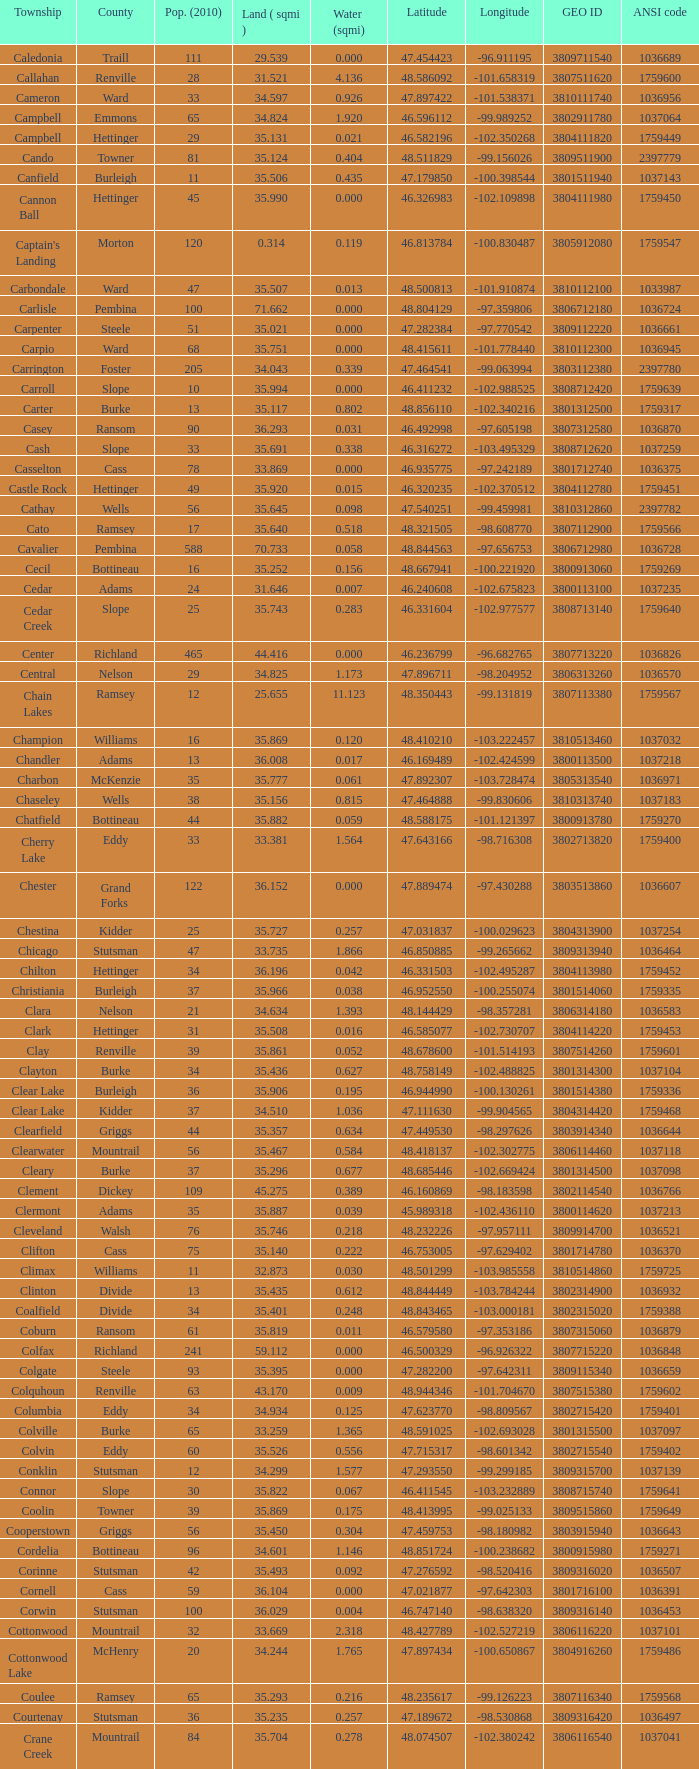What was the latitudinal position of the clearwater townsship? 48.418137. 